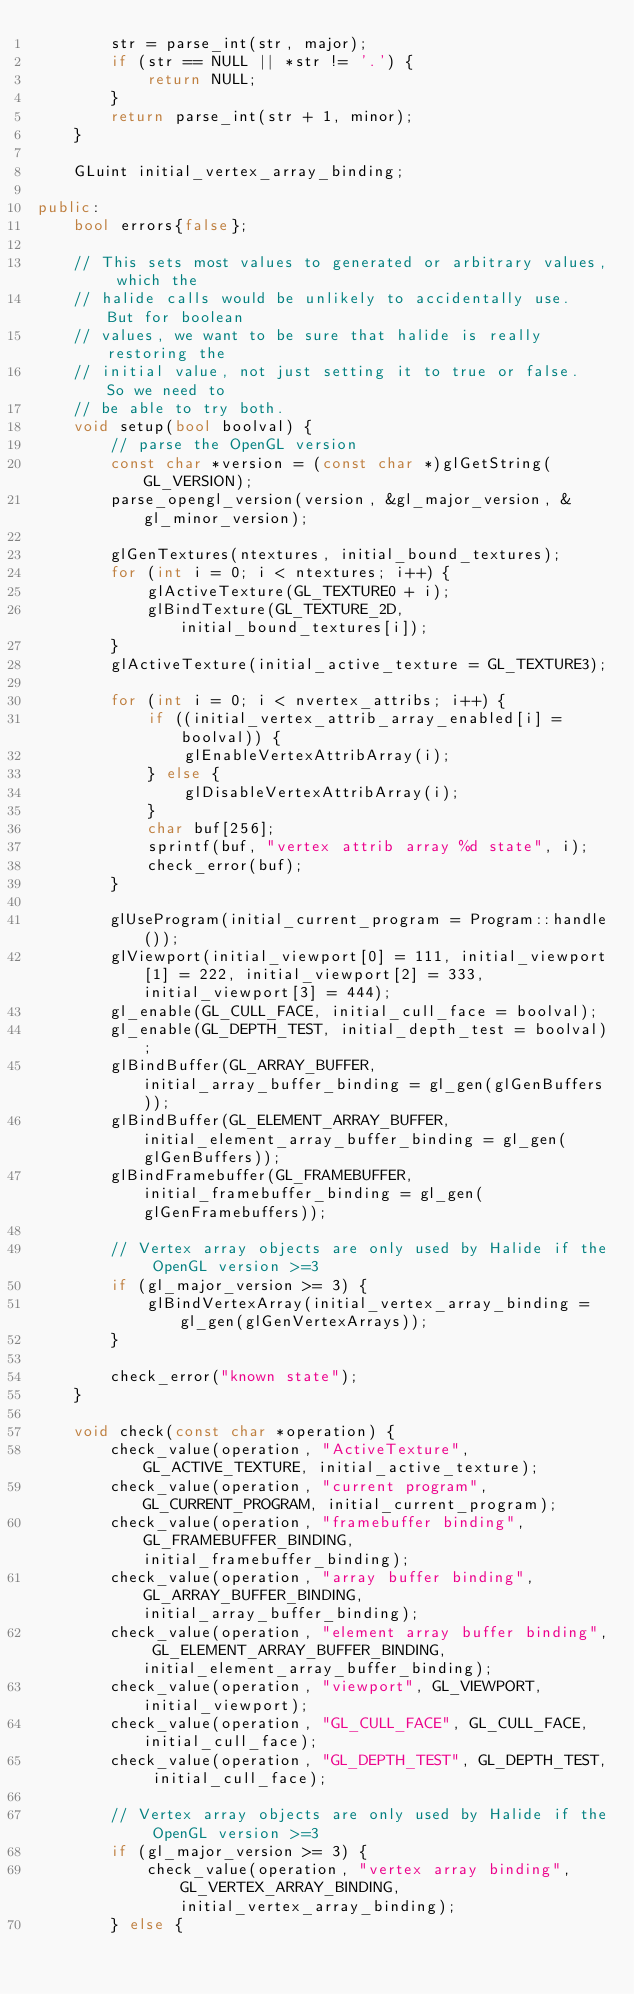<code> <loc_0><loc_0><loc_500><loc_500><_C++_>        str = parse_int(str, major);
        if (str == NULL || *str != '.') {
            return NULL;
        }
        return parse_int(str + 1, minor);
    }

    GLuint initial_vertex_array_binding;

public:
    bool errors{false};

    // This sets most values to generated or arbitrary values, which the
    // halide calls would be unlikely to accidentally use.  But for boolean
    // values, we want to be sure that halide is really restoring the
    // initial value, not just setting it to true or false.  So we need to
    // be able to try both.
    void setup(bool boolval) {
        // parse the OpenGL version
        const char *version = (const char *)glGetString(GL_VERSION);
        parse_opengl_version(version, &gl_major_version, &gl_minor_version);

        glGenTextures(ntextures, initial_bound_textures);
        for (int i = 0; i < ntextures; i++) {
            glActiveTexture(GL_TEXTURE0 + i);
            glBindTexture(GL_TEXTURE_2D, initial_bound_textures[i]);
        }
        glActiveTexture(initial_active_texture = GL_TEXTURE3);

        for (int i = 0; i < nvertex_attribs; i++) {
            if ((initial_vertex_attrib_array_enabled[i] = boolval)) {
                glEnableVertexAttribArray(i);
            } else {
                glDisableVertexAttribArray(i);
            }
            char buf[256];
            sprintf(buf, "vertex attrib array %d state", i);
            check_error(buf);
        }

        glUseProgram(initial_current_program = Program::handle());
        glViewport(initial_viewport[0] = 111, initial_viewport[1] = 222, initial_viewport[2] = 333, initial_viewport[3] = 444);
        gl_enable(GL_CULL_FACE, initial_cull_face = boolval);
        gl_enable(GL_DEPTH_TEST, initial_depth_test = boolval);
        glBindBuffer(GL_ARRAY_BUFFER, initial_array_buffer_binding = gl_gen(glGenBuffers));
        glBindBuffer(GL_ELEMENT_ARRAY_BUFFER, initial_element_array_buffer_binding = gl_gen(glGenBuffers));
        glBindFramebuffer(GL_FRAMEBUFFER, initial_framebuffer_binding = gl_gen(glGenFramebuffers));

        // Vertex array objects are only used by Halide if the OpenGL version >=3
        if (gl_major_version >= 3) {
            glBindVertexArray(initial_vertex_array_binding = gl_gen(glGenVertexArrays));
        }

        check_error("known state");
    }

    void check(const char *operation) {
        check_value(operation, "ActiveTexture", GL_ACTIVE_TEXTURE, initial_active_texture);
        check_value(operation, "current program", GL_CURRENT_PROGRAM, initial_current_program);
        check_value(operation, "framebuffer binding", GL_FRAMEBUFFER_BINDING, initial_framebuffer_binding);
        check_value(operation, "array buffer binding", GL_ARRAY_BUFFER_BINDING, initial_array_buffer_binding);
        check_value(operation, "element array buffer binding", GL_ELEMENT_ARRAY_BUFFER_BINDING, initial_element_array_buffer_binding);
        check_value(operation, "viewport", GL_VIEWPORT, initial_viewport);
        check_value(operation, "GL_CULL_FACE", GL_CULL_FACE, initial_cull_face);
        check_value(operation, "GL_DEPTH_TEST", GL_DEPTH_TEST, initial_cull_face);

        // Vertex array objects are only used by Halide if the OpenGL version >=3
        if (gl_major_version >= 3) {
            check_value(operation, "vertex array binding", GL_VERTEX_ARRAY_BINDING, initial_vertex_array_binding);
        } else {</code> 